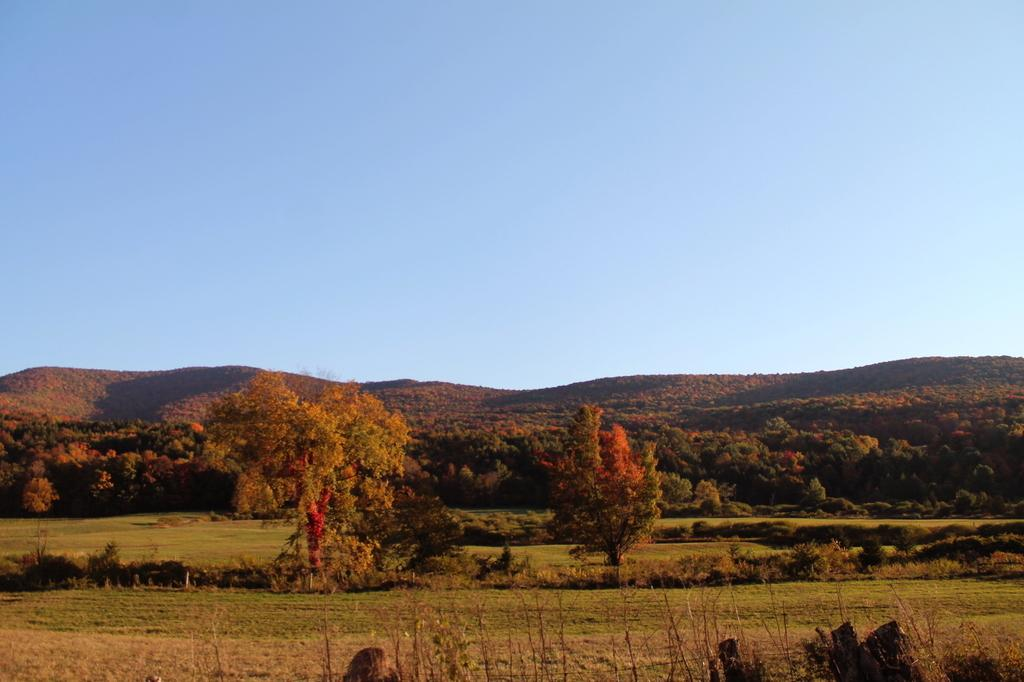What type of natural landform can be seen in the image? There are mountains in the image. What type of vegetation is present in the image? There are trees and plants in the image. What part of the natural environment is visible in the image? The sky is visible in the image. What is on the list that the mountains are holding in the image? There is no list present in the image, and the mountains are not holding anything. 